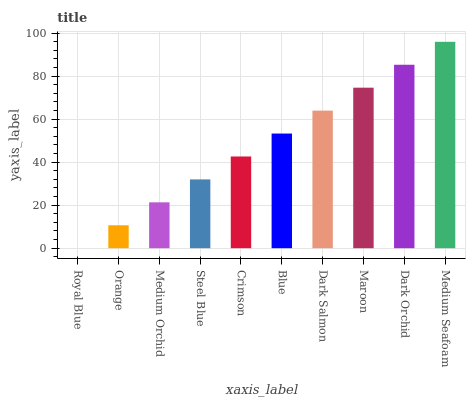Is Royal Blue the minimum?
Answer yes or no. Yes. Is Medium Seafoam the maximum?
Answer yes or no. Yes. Is Orange the minimum?
Answer yes or no. No. Is Orange the maximum?
Answer yes or no. No. Is Orange greater than Royal Blue?
Answer yes or no. Yes. Is Royal Blue less than Orange?
Answer yes or no. Yes. Is Royal Blue greater than Orange?
Answer yes or no. No. Is Orange less than Royal Blue?
Answer yes or no. No. Is Blue the high median?
Answer yes or no. Yes. Is Crimson the low median?
Answer yes or no. Yes. Is Crimson the high median?
Answer yes or no. No. Is Medium Orchid the low median?
Answer yes or no. No. 